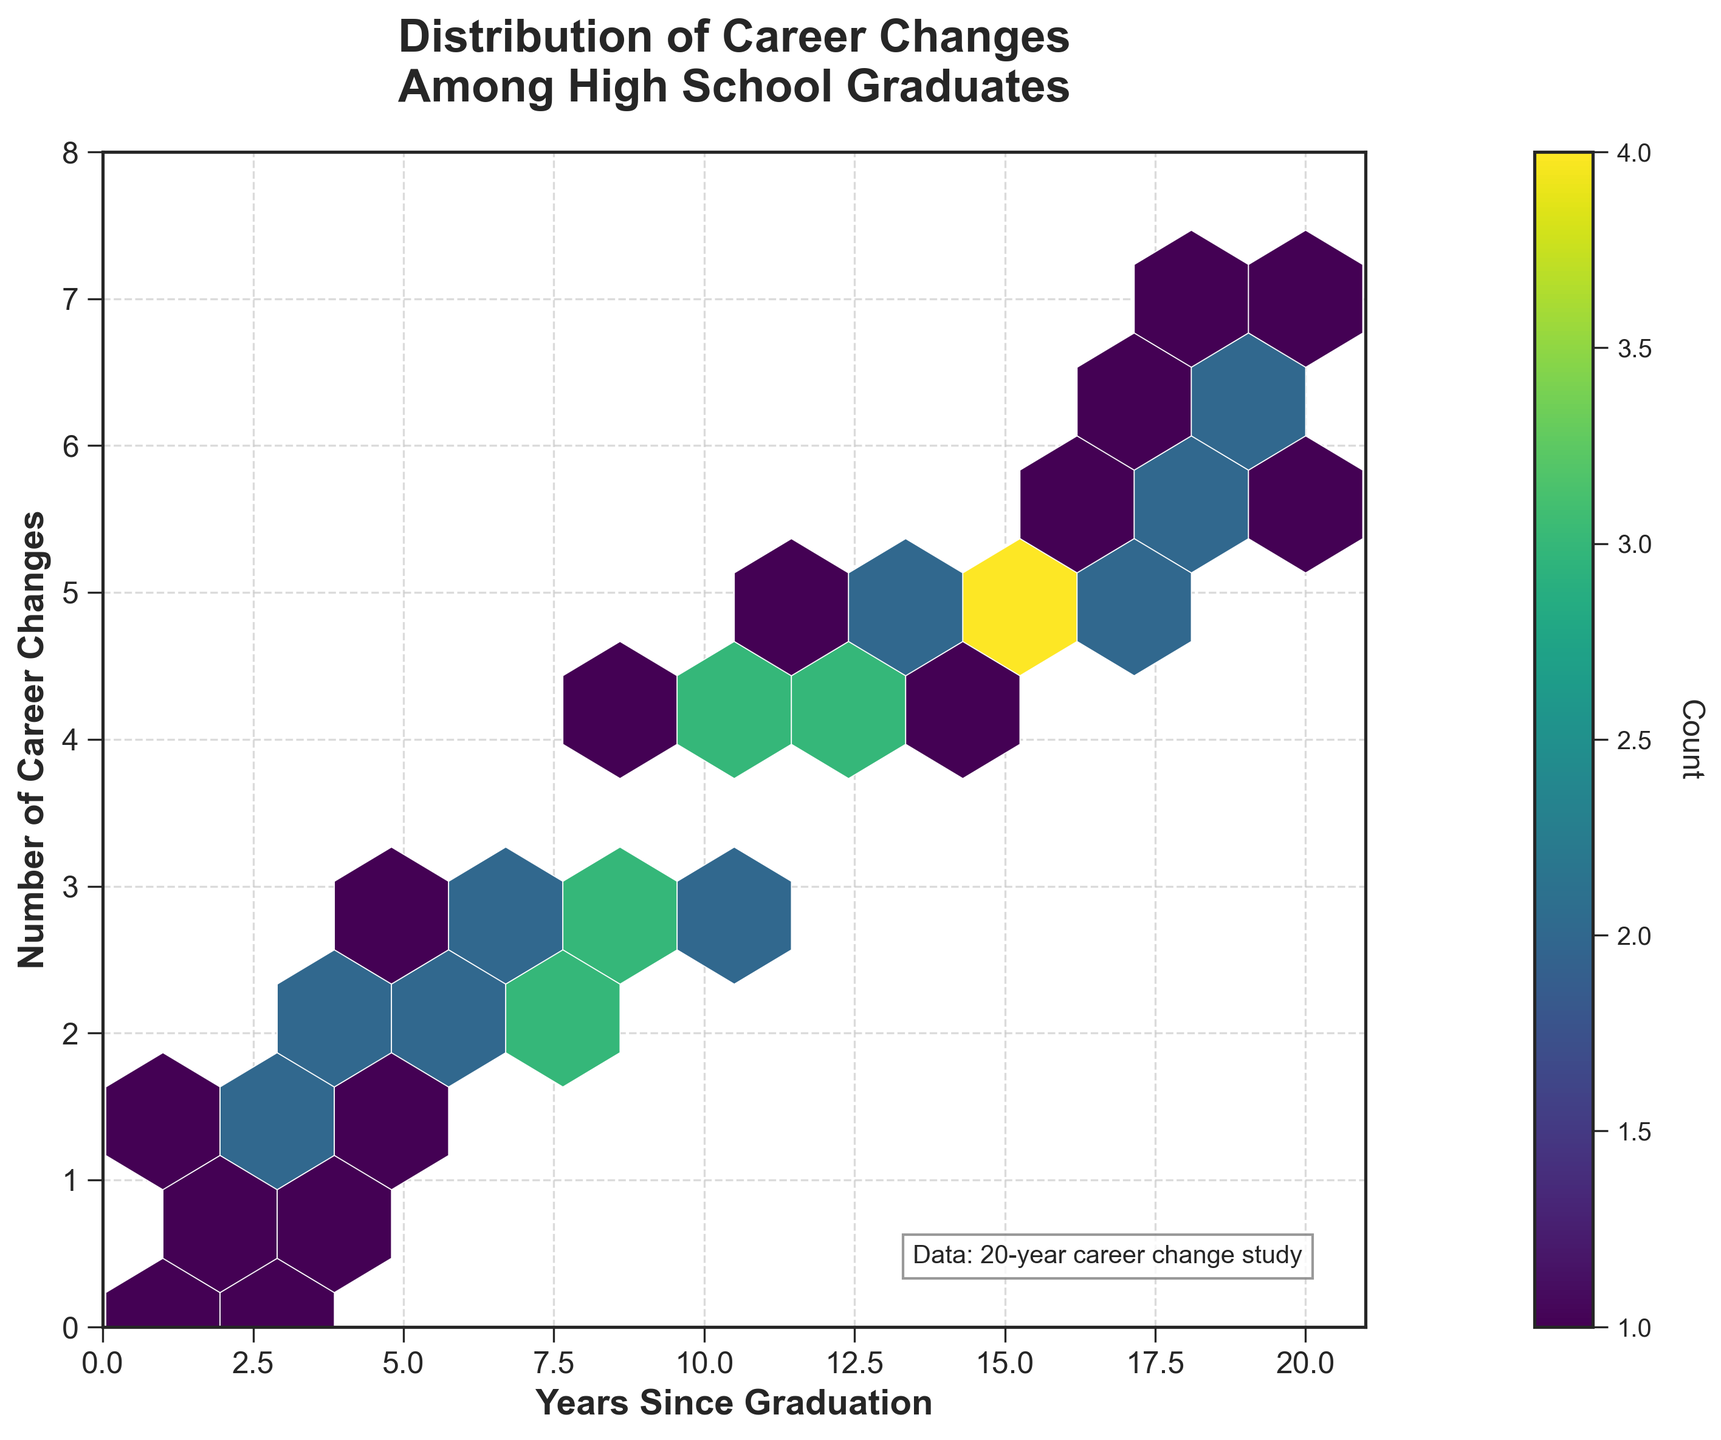What is the title of the hexbin plot? The title is located at the top of the figure and provides a summary of what the plot represents. It reads "Distribution of Career Changes Among High School Graduates".
Answer: Distribution of Career Changes Among High School Graduates What are the x and y axes labeled as in the plot? The x-axis label is "Years Since Graduation" and the y-axis label is "Number of Career Changes". These labels are placed horizontally and vertically along the respective axes.
Answer: Years Since Graduation, Number of Career Changes What is the color scheme used in this hexbin plot? The hexbin plot uses a viridis color palette, which transitions from blue to green to yellow representing lower to higher counts. This can be seen from the gradient bar on the right side of the plot.
Answer: Viridis How many years since graduation correspond to 5 career changes? By looking at the hexagons that align with 5 career changes on the y-axis, the plot shows that years since graduation corresponding to this include 15 and 16.
Answer: 15, 16 Which year(s) since graduation have the highest number of career changes? The highest number of career changes marked in the plot is 7. This can be observed at 20 years since graduation.
Answer: 20 Where do the highest densities of hexagons appear? The highest density of hexagons appears around 15-17 years since graduation and 5 career changes. This can be identified by the more saturated color in that region.
Answer: Around 15-17 years since graduation and 5 career changes What is the maximum number of career changes recorded? The y-axis shows the number of career changes, and the maximum visible on the plot is 7.
Answer: 7 Are there any years since graduation that show no career changes for graduates? Observing the x-axis and the plot, years 1 and 2 have zero career changes, as indicated by a few hexagons at the bottom.
Answer: 1, 2 How does the number of career changes evolve from 2 to 10 years since graduation? From 2 to 10 years since graduation, the number of career changes gradually increases, with hexagons indicating changes from 0 to 4 career changes over this period.
Answer: Gradually increases from 0 to 4 Is there any observable trend in career changes over time among graduates? The hexagon density and numbers indicate an increasing trend of career changes as the years since graduation rise, particularly clustering around 5 and 6 career changes after 15 years.
Answer: Increasing trend 